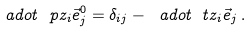Convert formula to latex. <formula><loc_0><loc_0><loc_500><loc_500>\ a d o t { \ p z _ { i } } { \vec { e } _ { j } ^ { 0 } } = \delta _ { i j } - \ a d o t { \ t z _ { i } } { \vec { e } _ { j } } \, .</formula> 